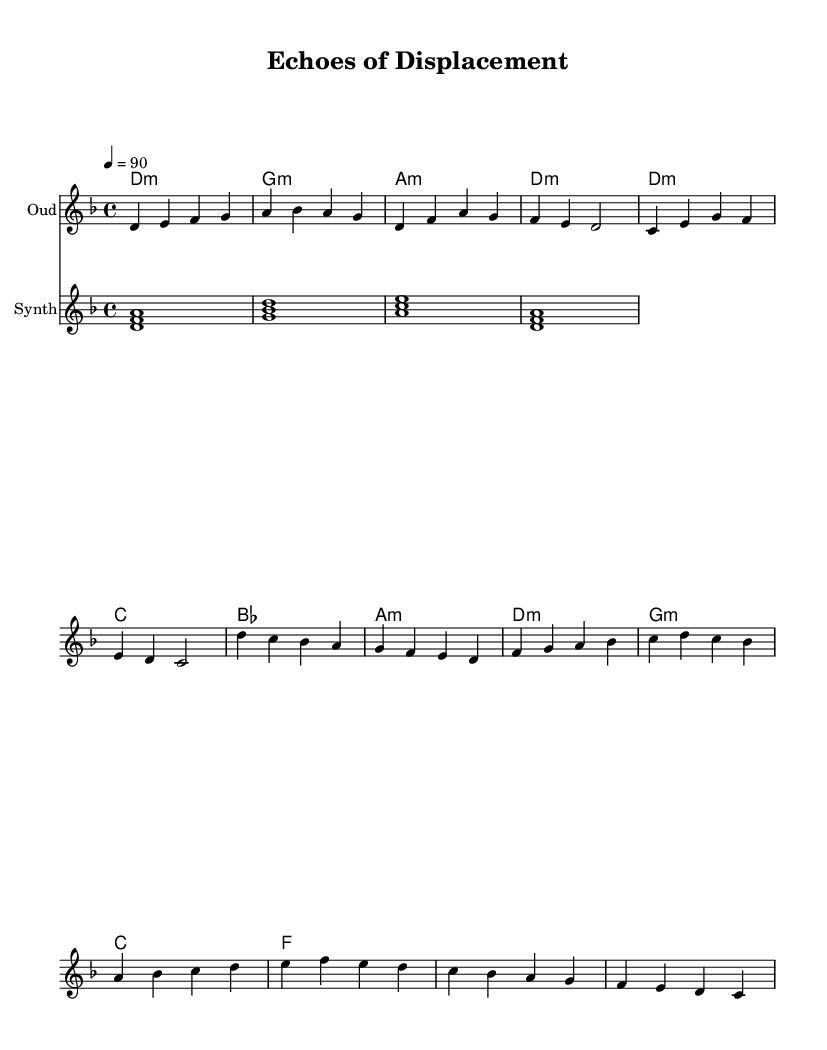What is the key signature of this music? The key signature is indicated at the beginning of the score, showing two flats (B♭ and E♭), which indicates the piece is in D minor.
Answer: D minor What is the time signature of this music? The time signature is found in the upper left corner of the score, corresponding to four beats per measure, which indicates a 4/4 time signature.
Answer: 4/4 What is the tempo marking for this piece? The tempo marking is visible at the start of the score, specifying the beat per minute for the piece, which is set at 90 beats per minute.
Answer: 90 How many measures are in the chorus section? The chorus section contains four measures, which can be counted directly from the music notation where the chorus is written.
Answer: 4 What type of synthesizer sound is used in the piece? The synthesizer part consists of simplified arpeggios that create a harmonic foundation, as indicated by the presence of stacked notes.
Answer: Arpeggios What chord is played during the intro? The intro includes a D minor chord, which is indicated as D:min in the chord names and represents the harmony for the introduction section.
Answer: D:min How does the oud part contribute to the theme of displacement? The oud's melodic lines are structured with emotional phrasing that conveys feelings of nostalgia and loss, reflective of themes associated with wartime displacement.
Answer: Emotional phrasing 